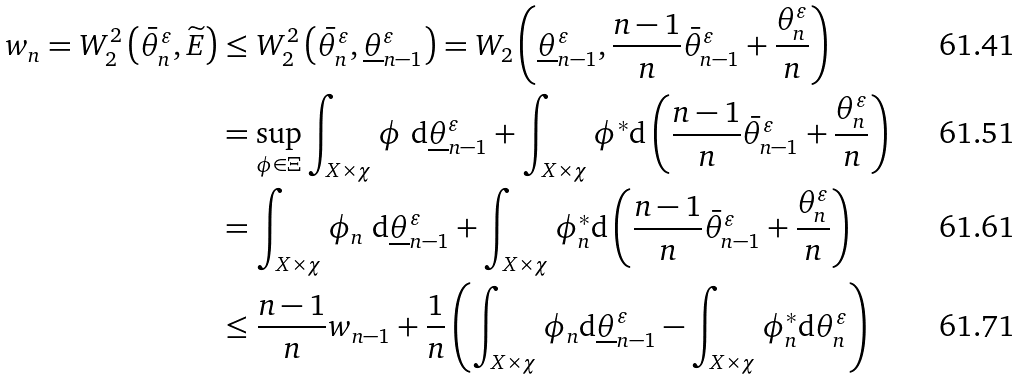<formula> <loc_0><loc_0><loc_500><loc_500>w _ { n } = W _ { 2 } ^ { 2 } \left ( \bar { \theta } _ { n } ^ { \varepsilon } , \widetilde { E } \right ) & \leq W _ { 2 } ^ { 2 } \left ( \bar { \theta } _ { n } ^ { \varepsilon } , \underline { \theta } _ { n - 1 } ^ { \varepsilon } \right ) = W _ { 2 } \left ( \underline { \theta } _ { n - 1 } ^ { \varepsilon } , \frac { n - 1 } { n } \bar { \theta } ^ { \varepsilon } _ { n - 1 } + \frac { \theta ^ { \varepsilon } _ { n } } { n } \right ) \\ & = \sup _ { \phi \in \Xi } \int _ { X \times \chi } \phi \ \mathrm d \underline { \theta } _ { n - 1 } ^ { \varepsilon } + \int _ { X \times \chi } \phi ^ { * } \mathrm d \left ( \frac { n - 1 } { n } \bar { \theta } ^ { \varepsilon } _ { n - 1 } + \frac { \theta ^ { \varepsilon } _ { n } } { n } \right ) \\ & = \int _ { X \times \chi } \phi _ { n } \ \mathrm d \underline { \theta } _ { n - 1 } ^ { \varepsilon } + \int _ { X \times \chi } \phi _ { n } ^ { * } \mathrm d \left ( \frac { n - 1 } { n } \bar { \theta } ^ { \varepsilon } _ { n - 1 } + \frac { \theta ^ { \varepsilon } _ { n } } { n } \right ) \\ & \leq \frac { n - 1 } { n } w _ { n - 1 } + \frac { 1 } { n } \left ( \int _ { X \times \chi } \phi _ { n } \mathrm d \underline { \theta } _ { n - 1 } ^ { \varepsilon } - \int _ { X \times \chi } \phi _ { n } ^ { * } \mathrm d \theta ^ { \varepsilon } _ { n } \right )</formula> 